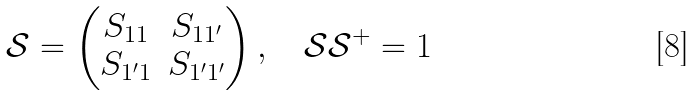Convert formula to latex. <formula><loc_0><loc_0><loc_500><loc_500>\mathcal { S } = \begin{pmatrix} S _ { 1 1 } & S _ { 1 1 ^ { \prime } } \\ S _ { 1 ^ { \prime } 1 } & S _ { 1 ^ { \prime } 1 ^ { \prime } } \\ \end{pmatrix} , \quad \mathcal { S } \mathcal { S } ^ { + } = 1</formula> 